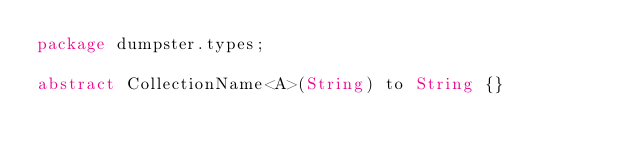Convert code to text. <code><loc_0><loc_0><loc_500><loc_500><_Haxe_>package dumpster.types;

abstract CollectionName<A>(String) to String {}</code> 